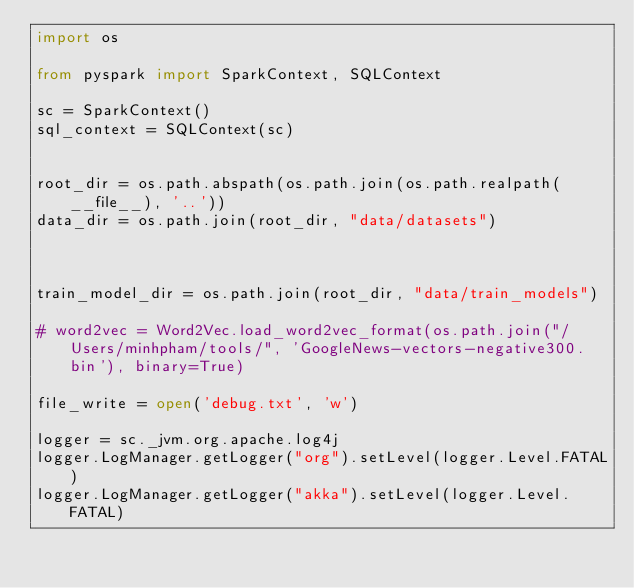Convert code to text. <code><loc_0><loc_0><loc_500><loc_500><_Python_>import os

from pyspark import SparkContext, SQLContext

sc = SparkContext()
sql_context = SQLContext(sc)


root_dir = os.path.abspath(os.path.join(os.path.realpath(__file__), '..'))
data_dir = os.path.join(root_dir, "data/datasets")



train_model_dir = os.path.join(root_dir, "data/train_models")

# word2vec = Word2Vec.load_word2vec_format(os.path.join("/Users/minhpham/tools/", 'GoogleNews-vectors-negative300.bin'), binary=True)

file_write = open('debug.txt', 'w')

logger = sc._jvm.org.apache.log4j
logger.LogManager.getLogger("org").setLevel(logger.Level.FATAL)
logger.LogManager.getLogger("akka").setLevel(logger.Level.FATAL)
</code> 